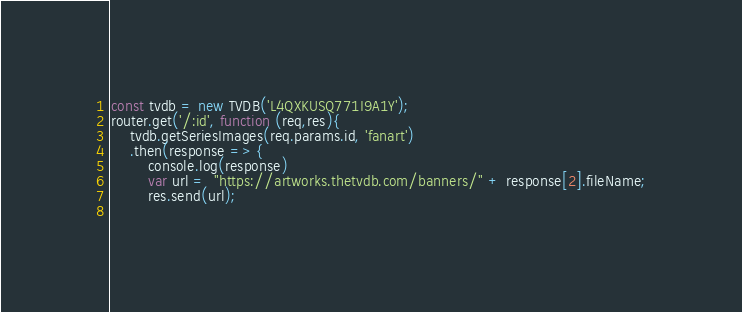<code> <loc_0><loc_0><loc_500><loc_500><_JavaScript_>const tvdb = new TVDB('L4QXKUSQ771I9A1Y');
router.get('/:id', function (req,res){
    tvdb.getSeriesImages(req.params.id, 'fanart')   
    .then(response => {
        console.log(response)
        var url =  "https://artworks.thetvdb.com/banners/" + response[2].fileName;
        res.send(url); 
    </code> 